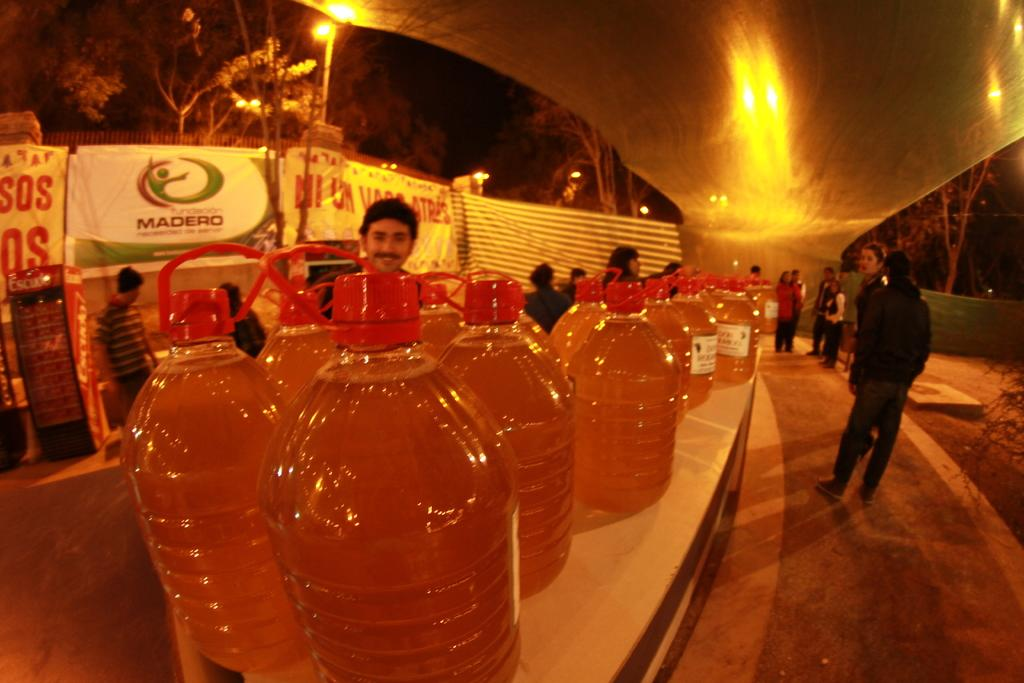<image>
Render a clear and concise summary of the photo. A man stands in front of a Madero sign. 